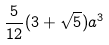<formula> <loc_0><loc_0><loc_500><loc_500>\frac { 5 } { 1 2 } ( 3 + \sqrt { 5 } ) a ^ { 3 }</formula> 